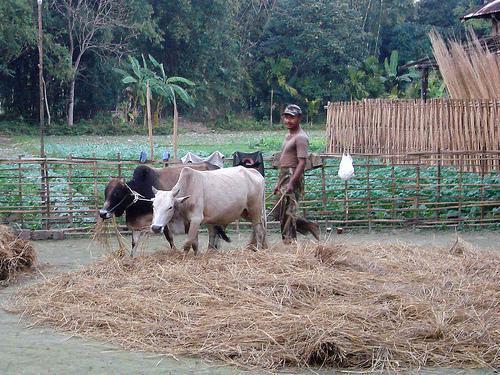How many people are in the photo?
Give a very brief answer. 1. How many cows are there?
Give a very brief answer. 2. 